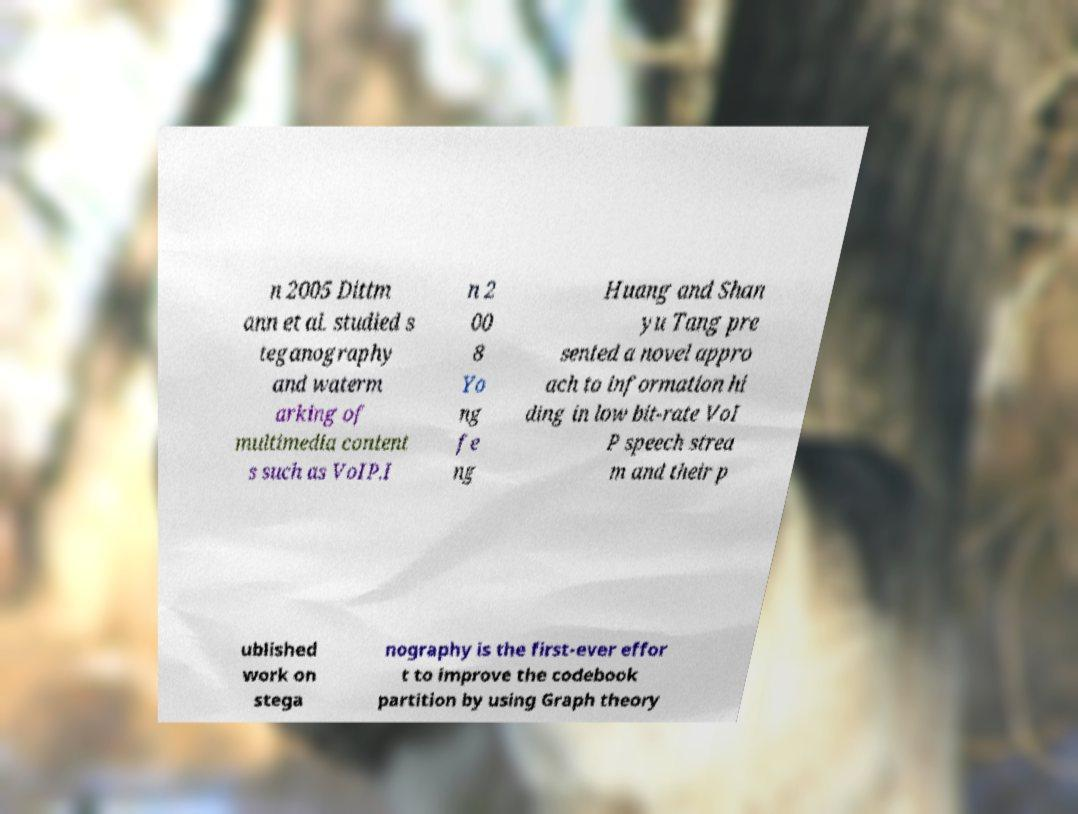Could you extract and type out the text from this image? n 2005 Dittm ann et al. studied s teganography and waterm arking of multimedia content s such as VoIP.I n 2 00 8 Yo ng fe ng Huang and Shan yu Tang pre sented a novel appro ach to information hi ding in low bit-rate VoI P speech strea m and their p ublished work on stega nography is the first-ever effor t to improve the codebook partition by using Graph theory 